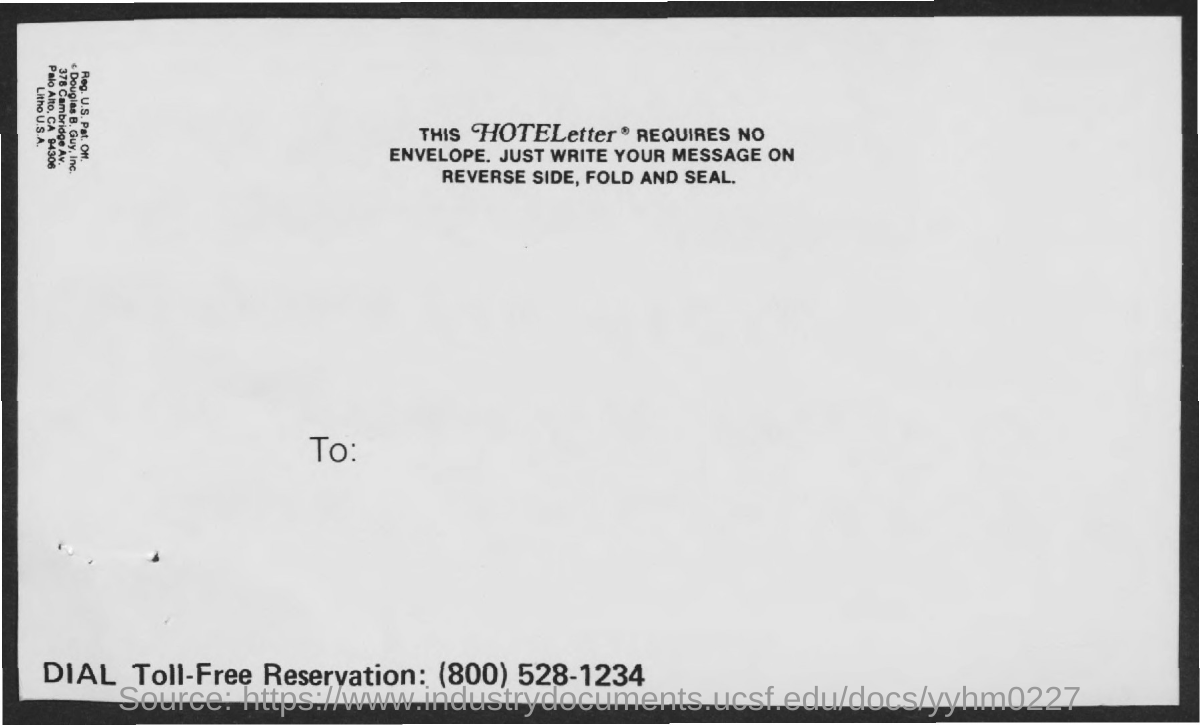Mention a couple of crucial points in this snapshot. The toll-free reservation number given is (800) 528-1234. 